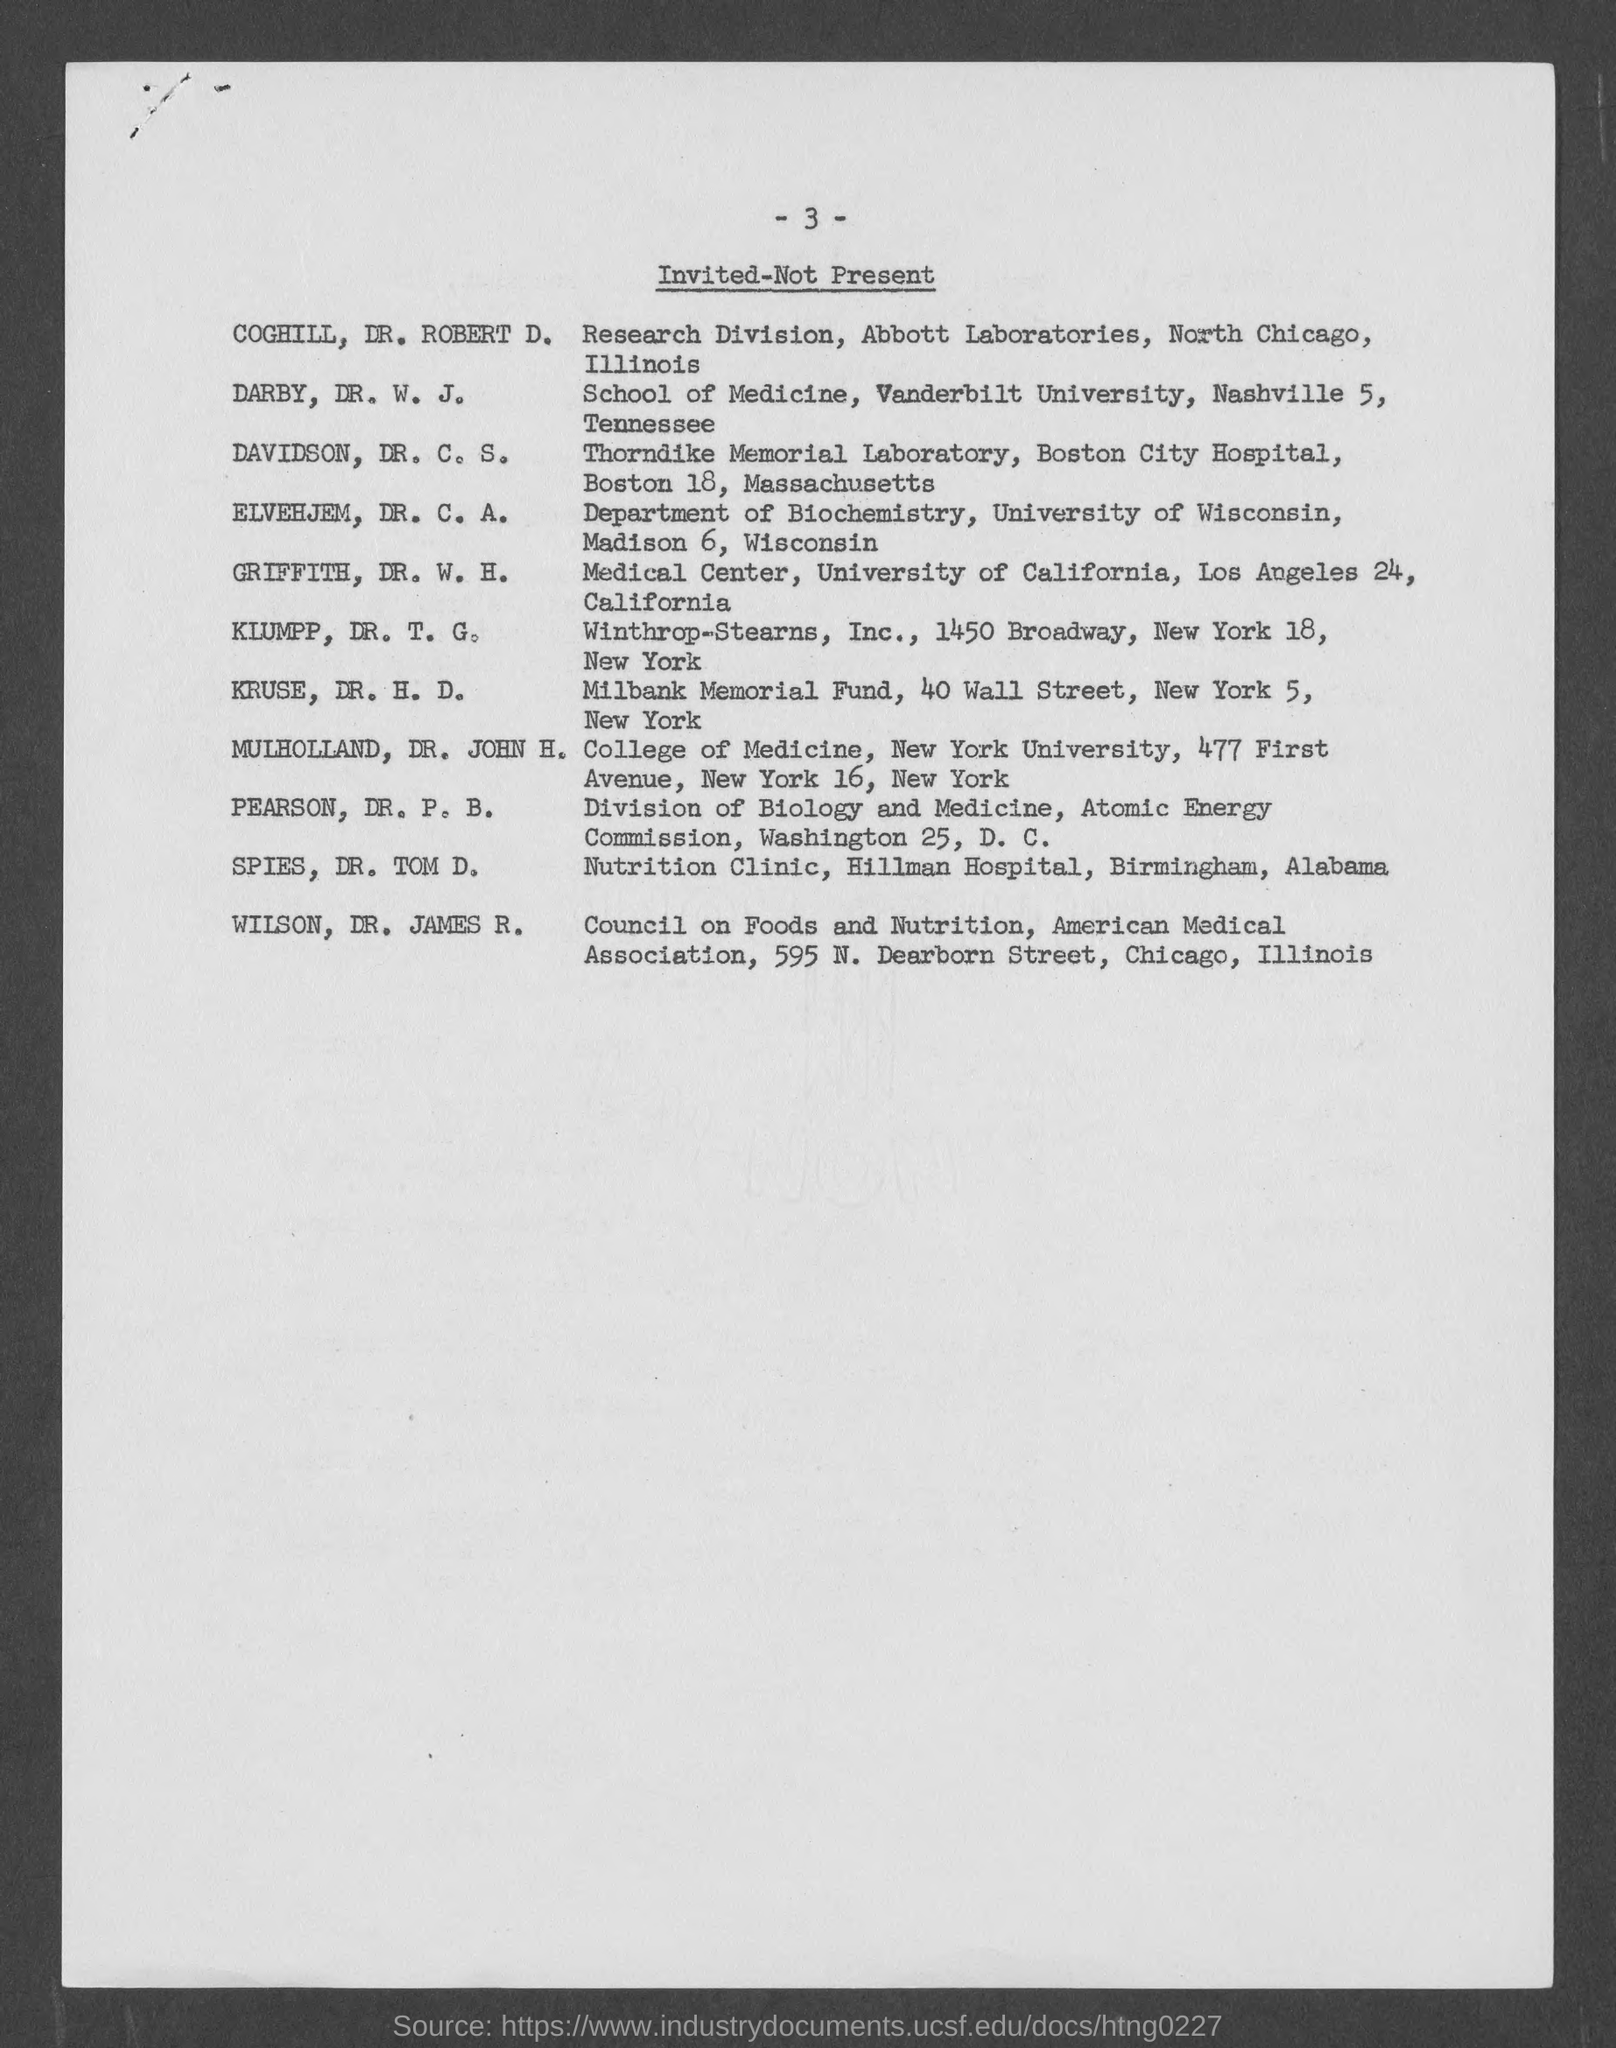Indicate a few pertinent items in this graphic. Dr. James R. Wilson belongs to the Council on Foods and Nutrition. Dr. ELVEHJEM works in the department of biochemistry. The document shows a list of individuals who were invited but were not present. Dr. Tom D. SPIES works at Hillman Hospital. The College of Medicine belongs to New York University. 